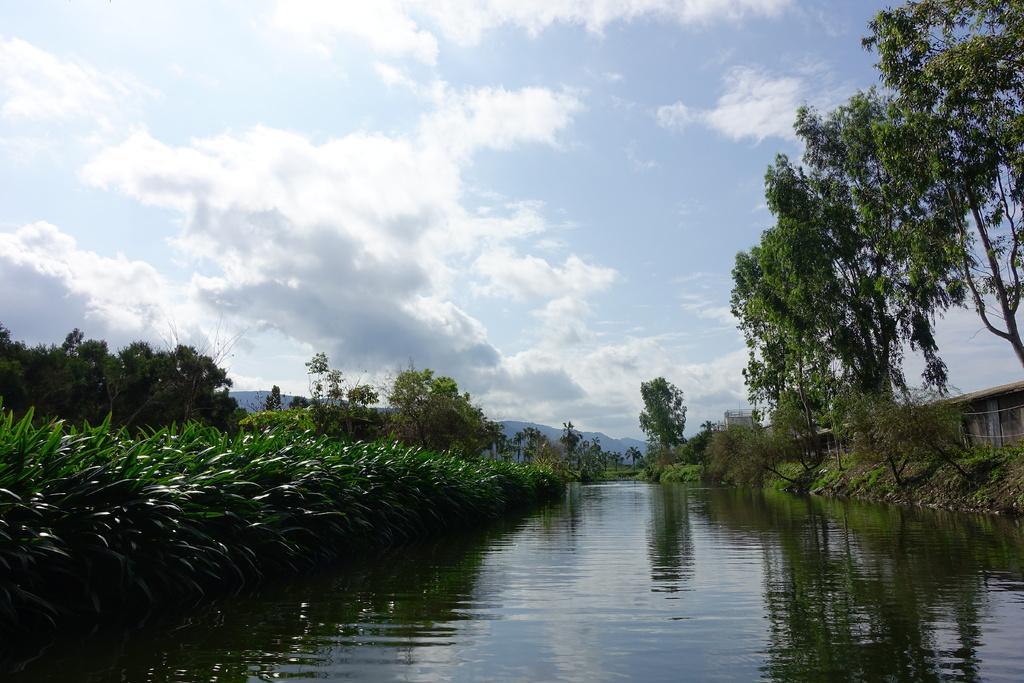Describe this image in one or two sentences. In the picture we can see a water and around it we can see plants, trees and sky with clouds. 